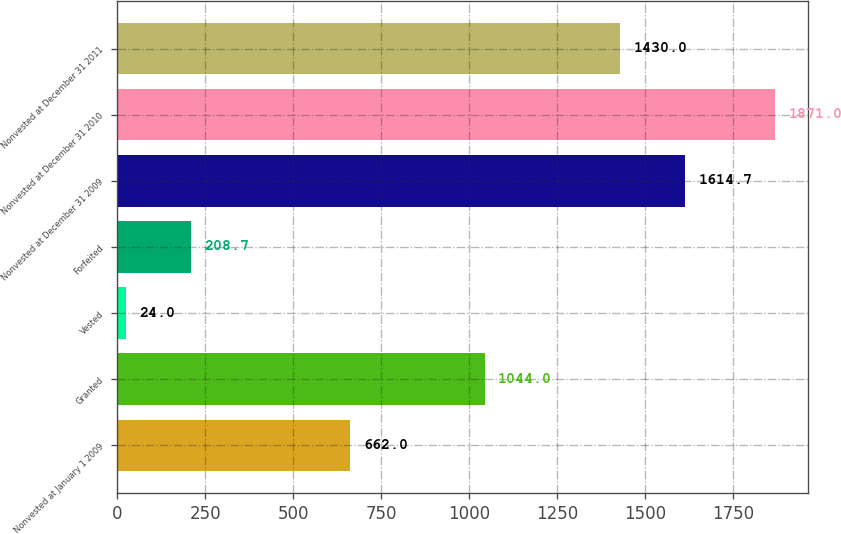Convert chart to OTSL. <chart><loc_0><loc_0><loc_500><loc_500><bar_chart><fcel>Nonvested at January 1 2009<fcel>Granted<fcel>Vested<fcel>Forfeited<fcel>Nonvested at December 31 2009<fcel>Nonvested at December 31 2010<fcel>Nonvested at December 31 2011<nl><fcel>662<fcel>1044<fcel>24<fcel>208.7<fcel>1614.7<fcel>1871<fcel>1430<nl></chart> 